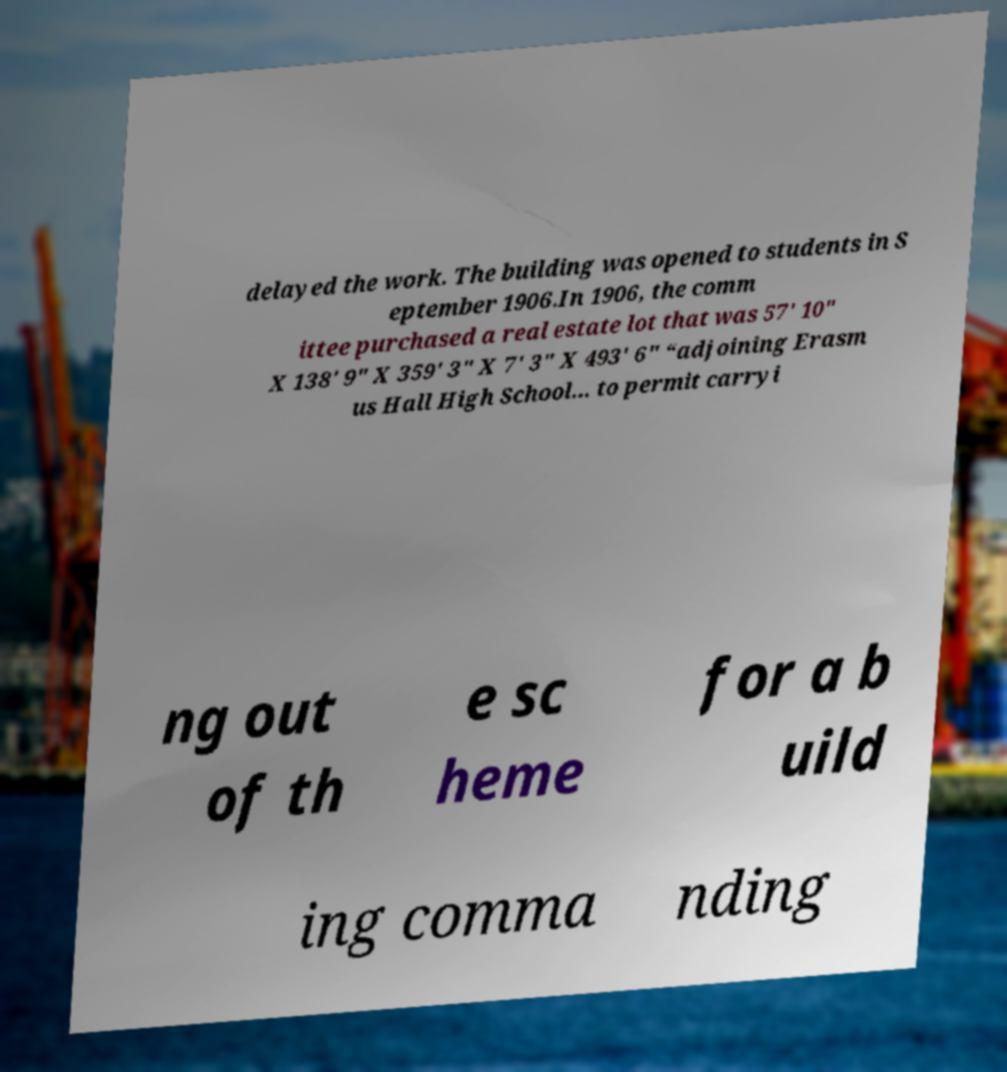Please identify and transcribe the text found in this image. delayed the work. The building was opened to students in S eptember 1906.In 1906, the comm ittee purchased a real estate lot that was 57' 10" X 138' 9" X 359' 3" X 7' 3" X 493' 6" “adjoining Erasm us Hall High School... to permit carryi ng out of th e sc heme for a b uild ing comma nding 